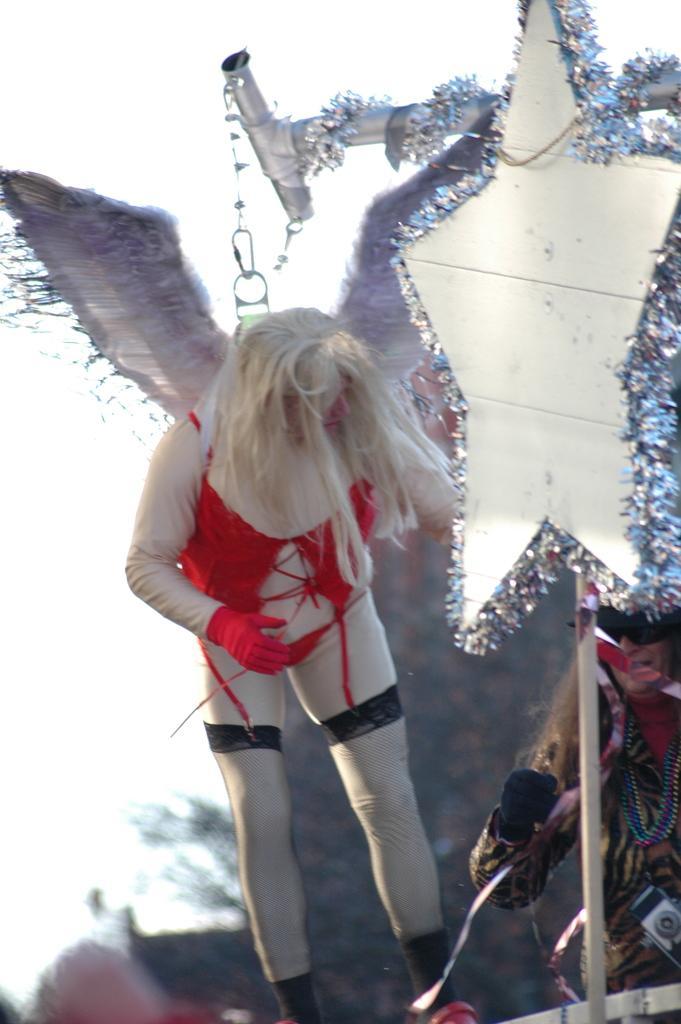Describe this image in one or two sentences. In this image we can see there is a lady standing with wings on her shoulder, beside her there is another person and there is a star attached to the pole with some decoration. In the background there is a sky. 